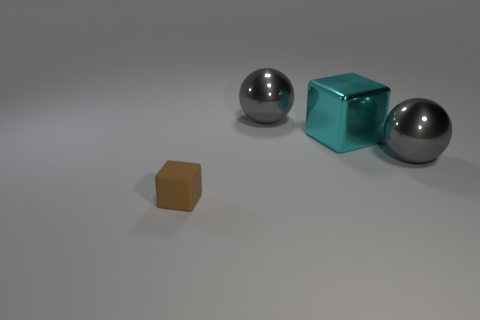Add 1 green rubber things. How many objects exist? 5 Add 3 small gray metal cylinders. How many small gray metal cylinders exist? 3 Subtract 0 brown balls. How many objects are left? 4 Subtract all big things. Subtract all large cyan shiny blocks. How many objects are left? 0 Add 2 tiny brown matte cubes. How many tiny brown matte cubes are left? 3 